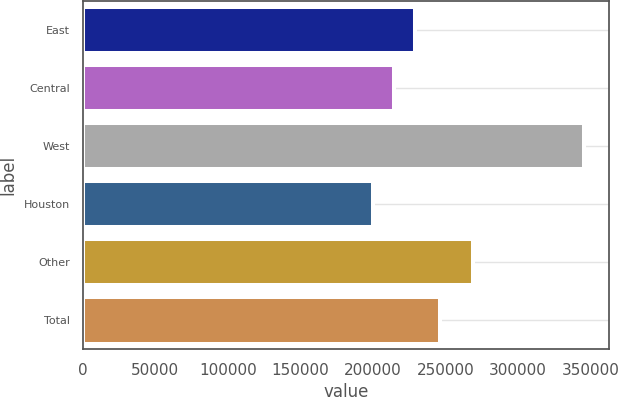Convert chart. <chart><loc_0><loc_0><loc_500><loc_500><bar_chart><fcel>East<fcel>Central<fcel>West<fcel>Houston<fcel>Other<fcel>Total<nl><fcel>229000<fcel>214500<fcel>345000<fcel>200000<fcel>269000<fcel>246000<nl></chart> 